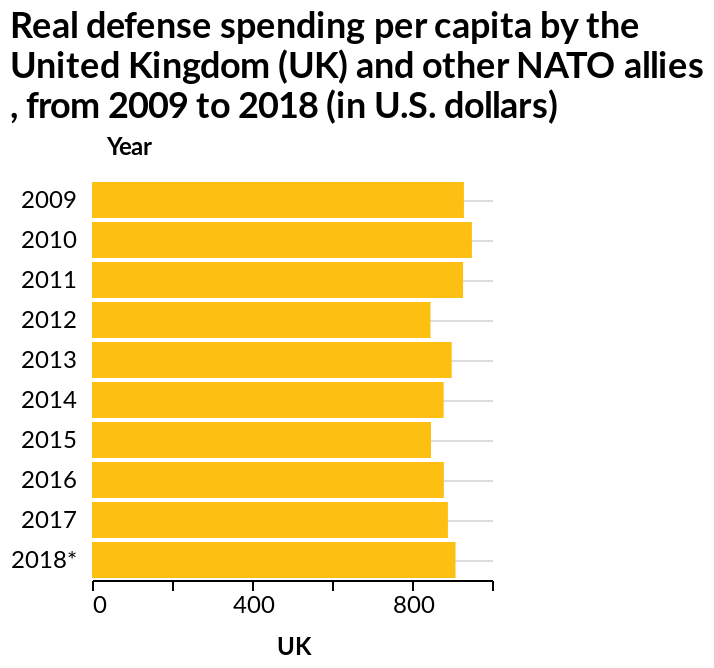<image>
please summary the statistics and relations of the chart The most spent by UK on defence was in 2010. Consistently there was a spend of over 800 in all years mentioned above. Which group of countries does the data in the bar chart represent? The data in the bar chart represents the United Kingdom (UK) and other NATO allies. 